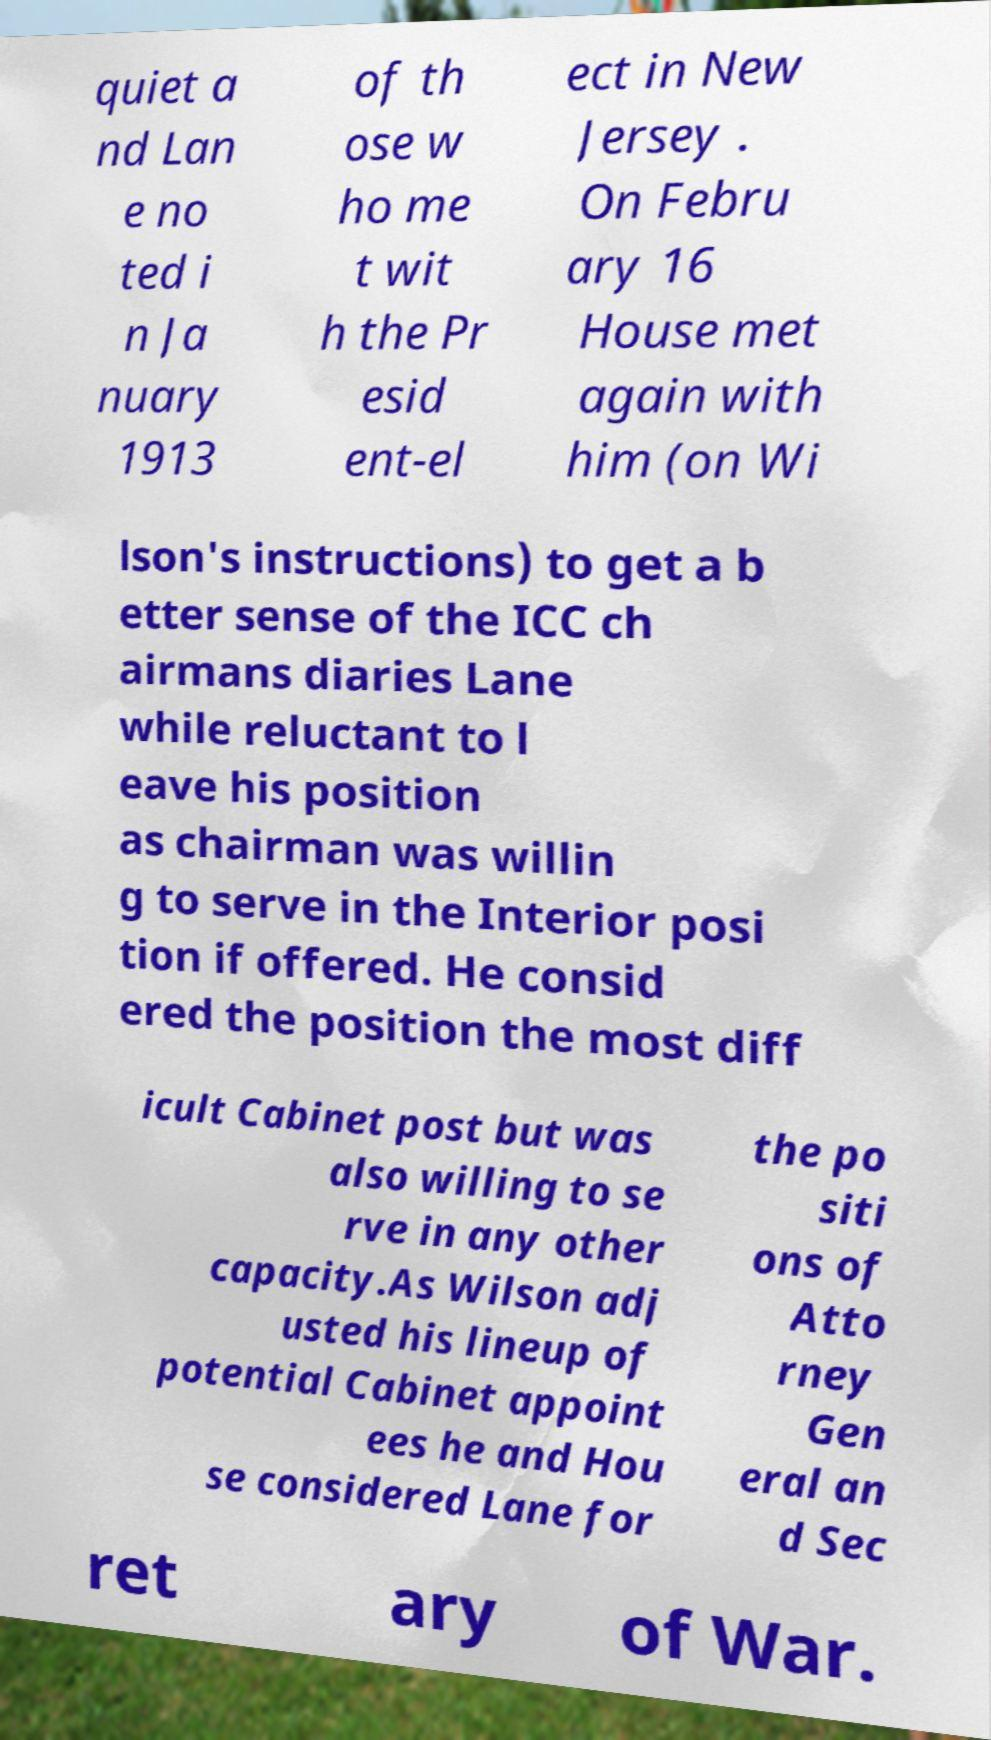Can you read and provide the text displayed in the image?This photo seems to have some interesting text. Can you extract and type it out for me? quiet a nd Lan e no ted i n Ja nuary 1913 of th ose w ho me t wit h the Pr esid ent-el ect in New Jersey . On Febru ary 16 House met again with him (on Wi lson's instructions) to get a b etter sense of the ICC ch airmans diaries Lane while reluctant to l eave his position as chairman was willin g to serve in the Interior posi tion if offered. He consid ered the position the most diff icult Cabinet post but was also willing to se rve in any other capacity.As Wilson adj usted his lineup of potential Cabinet appoint ees he and Hou se considered Lane for the po siti ons of Atto rney Gen eral an d Sec ret ary of War. 